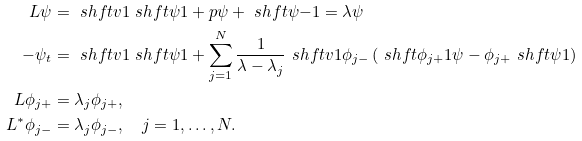Convert formula to latex. <formula><loc_0><loc_0><loc_500><loc_500>L \psi & = \ s h f t { v } { 1 } \ s h f t { \psi } { 1 } + p \psi + \ s h f t { \psi } { - 1 } = \lambda \psi \\ - \psi _ { t } & = \ s h f t { v } { 1 } \ s h f t { \psi } { 1 } + \sum _ { j = 1 } ^ { N } \frac { 1 } { \lambda - \lambda _ { j } } \ s h f t { v } { 1 } \phi _ { j - } \left ( \ s h f t { \phi _ { j + } } { 1 } \psi - \phi _ { j + } \ s h f t { \psi } { 1 } \right ) \\ L \phi _ { j + } & = \lambda _ { j } \phi _ { j + } , \\ L ^ { * } \phi _ { j - } & = \lambda _ { j } \phi _ { j - } , \quad j = 1 , \dots , N .</formula> 